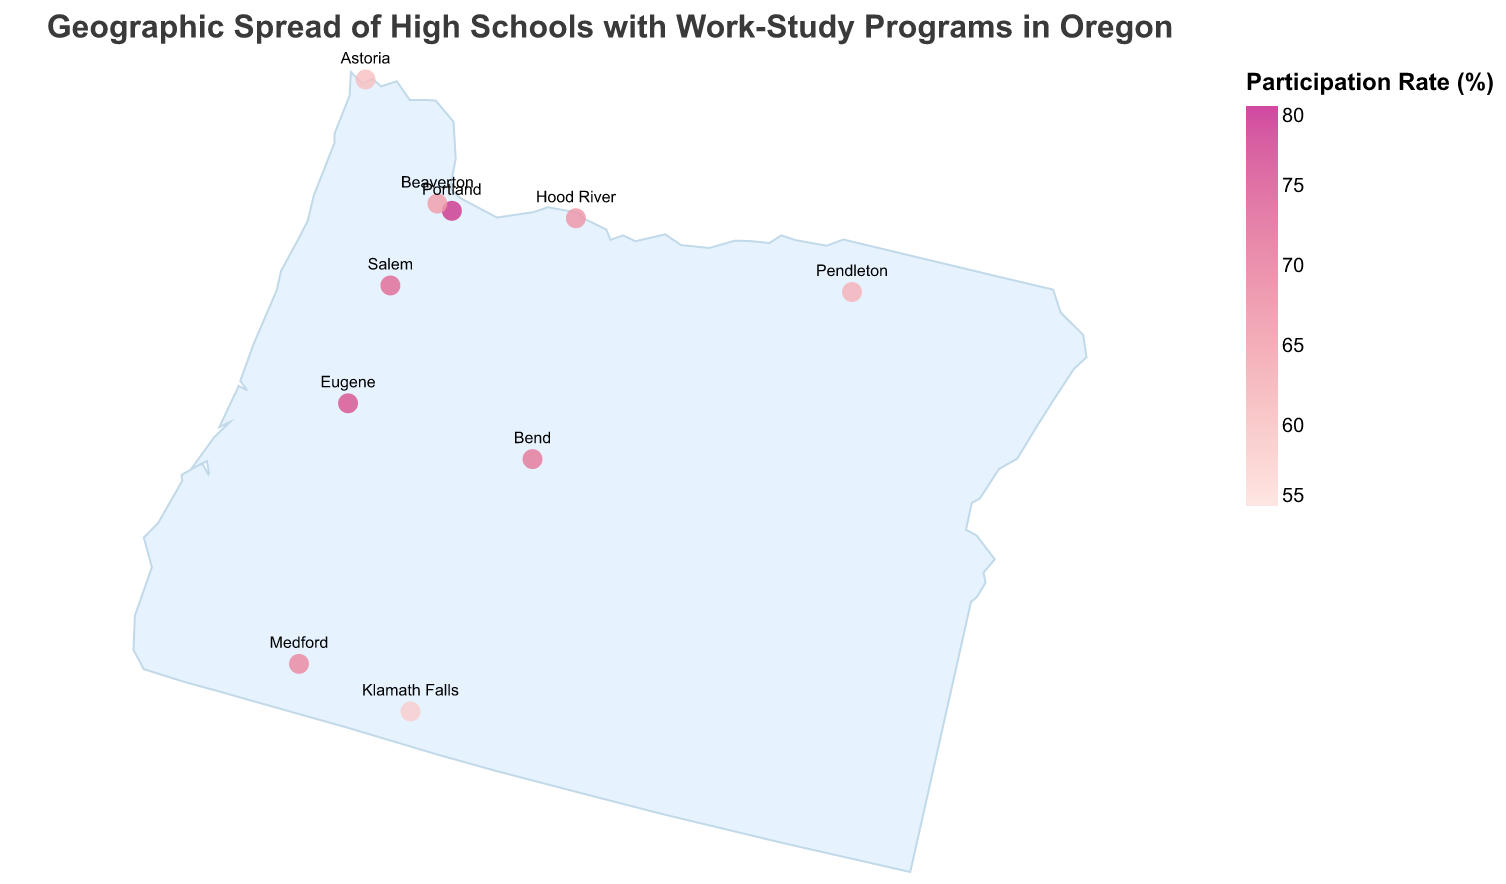Which high school has the highest participation rate in the work-study program? Look for the data point with the highest value in the "Work-Study Program Participation Rate" field. Lincoln High School has the highest rate at 78%.
Answer: Lincoln High School How many high schools have a participation rate above 70%? Count the number of high schools with a "Work-Study Program Participation Rate" greater than 70. There are three such high schools: Lincoln High School, South Salem High School, and North Eugene High School.
Answer: 3 What is the title of the figure? The title of the figure is displayed at the top and reads, "Geographic Spread of High Schools with Work-Study Programs in Oregon."
Answer: Geographic Spread of High Schools with Work-Study Programs in Oregon Which high school has the lowest participation rate in the work-study program? Look for the data point with the lowest value in the "Work-Study Program Participation Rate" field. Klamath Union High School has the lowest rate at 58%.
Answer: Klamath Union High School What is the average participation rate of all the high schools? Add up all participation rates and divide by the number of high schools: (78 + 65 + 72 + 70 + 68 + 62 + 75 + 60 + 58 + 66) / 10 = 67.4%.
Answer: 67.4% Which high school in Medford has a work-study program participation rate and how does it compare to the average rate? Medford High School in Medford has a participation rate of 68%. The average participation rate of all high schools is 67.4%. Medford's participation rate is slightly above average.
Answer: Medford High School, above average Are there more high schools with a participation rate below or above 65%? Count the number of high schools with participation rates below and above 65%. Below 65%: 4 schools (Pendleton High School, Astoria High School, Klamath Union High School), Above 65%: 6 schools (Lincoln High School, Sunset High School, South Salem High School, Bend Senior High School, Medford High School, North Eugene High School, Hood River Valley High School). There are more schools above 65%.
Answer: Above 65% Which city has two high schools with work-study program participation rates, and what are their rates? Locate the city that appears more than once in the list. Only Portland is listed with two high schools. The participation rates for Lincoln High School (78%) and Sunset High School (65%).
Answer: Portland, 78% and 65% Do any high schools have a participation rate exactly equal to 68%? Look through the data points for an exact match in the "Work-Study Program Participation Rate" field. Medford High School has a participation rate of 68%.
Answer: Medford High School What is the most common range of participation rates among these high schools? Group the participation rates into ranges (e.g., 55-60%, 61-65%, 66-70%, 71-75%, 76-80%). The most values fall within the 66-70% range (Sunset High School, Bend Senior High School, Medford High School, Hood River Valley High School).
Answer: 66-70% 